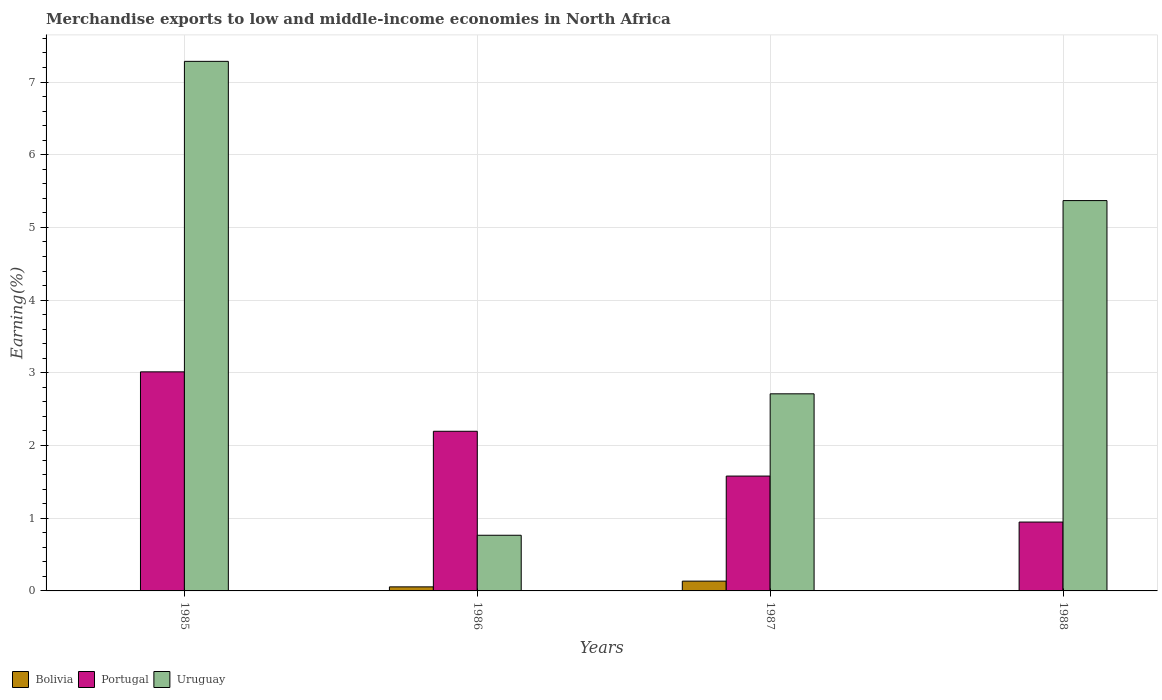How many groups of bars are there?
Provide a short and direct response. 4. How many bars are there on the 2nd tick from the left?
Your answer should be very brief. 3. How many bars are there on the 3rd tick from the right?
Keep it short and to the point. 3. What is the label of the 4th group of bars from the left?
Offer a very short reply. 1988. What is the percentage of amount earned from merchandise exports in Uruguay in 1985?
Offer a very short reply. 7.28. Across all years, what is the maximum percentage of amount earned from merchandise exports in Portugal?
Your answer should be compact. 3.01. Across all years, what is the minimum percentage of amount earned from merchandise exports in Portugal?
Keep it short and to the point. 0.95. In which year was the percentage of amount earned from merchandise exports in Bolivia maximum?
Provide a succinct answer. 1987. What is the total percentage of amount earned from merchandise exports in Bolivia in the graph?
Give a very brief answer. 0.2. What is the difference between the percentage of amount earned from merchandise exports in Portugal in 1985 and that in 1986?
Your response must be concise. 0.82. What is the difference between the percentage of amount earned from merchandise exports in Portugal in 1988 and the percentage of amount earned from merchandise exports in Uruguay in 1985?
Keep it short and to the point. -6.34. What is the average percentage of amount earned from merchandise exports in Uruguay per year?
Give a very brief answer. 4.03. In the year 1985, what is the difference between the percentage of amount earned from merchandise exports in Bolivia and percentage of amount earned from merchandise exports in Portugal?
Your response must be concise. -3.01. What is the ratio of the percentage of amount earned from merchandise exports in Bolivia in 1986 to that in 1988?
Make the answer very short. 13.66. Is the percentage of amount earned from merchandise exports in Bolivia in 1986 less than that in 1988?
Provide a succinct answer. No. Is the difference between the percentage of amount earned from merchandise exports in Bolivia in 1985 and 1988 greater than the difference between the percentage of amount earned from merchandise exports in Portugal in 1985 and 1988?
Your answer should be compact. No. What is the difference between the highest and the second highest percentage of amount earned from merchandise exports in Bolivia?
Ensure brevity in your answer.  0.08. What is the difference between the highest and the lowest percentage of amount earned from merchandise exports in Portugal?
Ensure brevity in your answer.  2.07. In how many years, is the percentage of amount earned from merchandise exports in Portugal greater than the average percentage of amount earned from merchandise exports in Portugal taken over all years?
Offer a very short reply. 2. What does the 2nd bar from the left in 1985 represents?
Keep it short and to the point. Portugal. What does the 1st bar from the right in 1988 represents?
Your answer should be compact. Uruguay. Are all the bars in the graph horizontal?
Your response must be concise. No. How many years are there in the graph?
Make the answer very short. 4. Does the graph contain grids?
Provide a short and direct response. Yes. What is the title of the graph?
Your answer should be compact. Merchandise exports to low and middle-income economies in North Africa. Does "Nepal" appear as one of the legend labels in the graph?
Provide a succinct answer. No. What is the label or title of the X-axis?
Ensure brevity in your answer.  Years. What is the label or title of the Y-axis?
Provide a succinct answer. Earning(%). What is the Earning(%) of Bolivia in 1985?
Your answer should be compact. 0. What is the Earning(%) in Portugal in 1985?
Ensure brevity in your answer.  3.01. What is the Earning(%) of Uruguay in 1985?
Provide a succinct answer. 7.28. What is the Earning(%) in Bolivia in 1986?
Offer a very short reply. 0.06. What is the Earning(%) of Portugal in 1986?
Offer a very short reply. 2.2. What is the Earning(%) of Uruguay in 1986?
Offer a very short reply. 0.77. What is the Earning(%) in Bolivia in 1987?
Your response must be concise. 0.13. What is the Earning(%) of Portugal in 1987?
Give a very brief answer. 1.58. What is the Earning(%) in Uruguay in 1987?
Give a very brief answer. 2.71. What is the Earning(%) of Bolivia in 1988?
Offer a very short reply. 0. What is the Earning(%) of Portugal in 1988?
Give a very brief answer. 0.95. What is the Earning(%) of Uruguay in 1988?
Provide a succinct answer. 5.37. Across all years, what is the maximum Earning(%) in Bolivia?
Keep it short and to the point. 0.13. Across all years, what is the maximum Earning(%) of Portugal?
Ensure brevity in your answer.  3.01. Across all years, what is the maximum Earning(%) of Uruguay?
Keep it short and to the point. 7.28. Across all years, what is the minimum Earning(%) of Bolivia?
Ensure brevity in your answer.  0. Across all years, what is the minimum Earning(%) of Portugal?
Keep it short and to the point. 0.95. Across all years, what is the minimum Earning(%) in Uruguay?
Your response must be concise. 0.77. What is the total Earning(%) in Bolivia in the graph?
Keep it short and to the point. 0.2. What is the total Earning(%) in Portugal in the graph?
Offer a very short reply. 7.74. What is the total Earning(%) of Uruguay in the graph?
Keep it short and to the point. 16.13. What is the difference between the Earning(%) of Bolivia in 1985 and that in 1986?
Your response must be concise. -0.06. What is the difference between the Earning(%) in Portugal in 1985 and that in 1986?
Ensure brevity in your answer.  0.82. What is the difference between the Earning(%) in Uruguay in 1985 and that in 1986?
Offer a terse response. 6.52. What is the difference between the Earning(%) in Bolivia in 1985 and that in 1987?
Give a very brief answer. -0.13. What is the difference between the Earning(%) in Portugal in 1985 and that in 1987?
Make the answer very short. 1.43. What is the difference between the Earning(%) in Uruguay in 1985 and that in 1987?
Give a very brief answer. 4.57. What is the difference between the Earning(%) of Bolivia in 1985 and that in 1988?
Give a very brief answer. -0. What is the difference between the Earning(%) of Portugal in 1985 and that in 1988?
Provide a short and direct response. 2.07. What is the difference between the Earning(%) of Uruguay in 1985 and that in 1988?
Provide a short and direct response. 1.92. What is the difference between the Earning(%) of Bolivia in 1986 and that in 1987?
Give a very brief answer. -0.08. What is the difference between the Earning(%) of Portugal in 1986 and that in 1987?
Your response must be concise. 0.62. What is the difference between the Earning(%) of Uruguay in 1986 and that in 1987?
Keep it short and to the point. -1.95. What is the difference between the Earning(%) of Bolivia in 1986 and that in 1988?
Offer a very short reply. 0.05. What is the difference between the Earning(%) in Portugal in 1986 and that in 1988?
Your answer should be compact. 1.25. What is the difference between the Earning(%) in Uruguay in 1986 and that in 1988?
Provide a short and direct response. -4.6. What is the difference between the Earning(%) of Bolivia in 1987 and that in 1988?
Offer a very short reply. 0.13. What is the difference between the Earning(%) of Portugal in 1987 and that in 1988?
Your answer should be very brief. 0.63. What is the difference between the Earning(%) of Uruguay in 1987 and that in 1988?
Make the answer very short. -2.66. What is the difference between the Earning(%) in Bolivia in 1985 and the Earning(%) in Portugal in 1986?
Offer a very short reply. -2.2. What is the difference between the Earning(%) of Bolivia in 1985 and the Earning(%) of Uruguay in 1986?
Make the answer very short. -0.77. What is the difference between the Earning(%) in Portugal in 1985 and the Earning(%) in Uruguay in 1986?
Make the answer very short. 2.25. What is the difference between the Earning(%) in Bolivia in 1985 and the Earning(%) in Portugal in 1987?
Offer a terse response. -1.58. What is the difference between the Earning(%) in Bolivia in 1985 and the Earning(%) in Uruguay in 1987?
Offer a very short reply. -2.71. What is the difference between the Earning(%) in Portugal in 1985 and the Earning(%) in Uruguay in 1987?
Your response must be concise. 0.3. What is the difference between the Earning(%) of Bolivia in 1985 and the Earning(%) of Portugal in 1988?
Offer a very short reply. -0.95. What is the difference between the Earning(%) of Bolivia in 1985 and the Earning(%) of Uruguay in 1988?
Ensure brevity in your answer.  -5.37. What is the difference between the Earning(%) of Portugal in 1985 and the Earning(%) of Uruguay in 1988?
Provide a short and direct response. -2.36. What is the difference between the Earning(%) of Bolivia in 1986 and the Earning(%) of Portugal in 1987?
Your answer should be compact. -1.52. What is the difference between the Earning(%) in Bolivia in 1986 and the Earning(%) in Uruguay in 1987?
Give a very brief answer. -2.66. What is the difference between the Earning(%) of Portugal in 1986 and the Earning(%) of Uruguay in 1987?
Provide a short and direct response. -0.52. What is the difference between the Earning(%) of Bolivia in 1986 and the Earning(%) of Portugal in 1988?
Keep it short and to the point. -0.89. What is the difference between the Earning(%) in Bolivia in 1986 and the Earning(%) in Uruguay in 1988?
Offer a very short reply. -5.31. What is the difference between the Earning(%) in Portugal in 1986 and the Earning(%) in Uruguay in 1988?
Provide a succinct answer. -3.17. What is the difference between the Earning(%) in Bolivia in 1987 and the Earning(%) in Portugal in 1988?
Offer a terse response. -0.81. What is the difference between the Earning(%) of Bolivia in 1987 and the Earning(%) of Uruguay in 1988?
Make the answer very short. -5.23. What is the difference between the Earning(%) in Portugal in 1987 and the Earning(%) in Uruguay in 1988?
Your answer should be very brief. -3.79. What is the average Earning(%) of Bolivia per year?
Your response must be concise. 0.05. What is the average Earning(%) in Portugal per year?
Provide a short and direct response. 1.93. What is the average Earning(%) of Uruguay per year?
Offer a very short reply. 4.03. In the year 1985, what is the difference between the Earning(%) of Bolivia and Earning(%) of Portugal?
Give a very brief answer. -3.01. In the year 1985, what is the difference between the Earning(%) of Bolivia and Earning(%) of Uruguay?
Give a very brief answer. -7.28. In the year 1985, what is the difference between the Earning(%) in Portugal and Earning(%) in Uruguay?
Ensure brevity in your answer.  -4.27. In the year 1986, what is the difference between the Earning(%) in Bolivia and Earning(%) in Portugal?
Your answer should be compact. -2.14. In the year 1986, what is the difference between the Earning(%) of Bolivia and Earning(%) of Uruguay?
Ensure brevity in your answer.  -0.71. In the year 1986, what is the difference between the Earning(%) in Portugal and Earning(%) in Uruguay?
Your response must be concise. 1.43. In the year 1987, what is the difference between the Earning(%) in Bolivia and Earning(%) in Portugal?
Offer a very short reply. -1.45. In the year 1987, what is the difference between the Earning(%) of Bolivia and Earning(%) of Uruguay?
Your response must be concise. -2.58. In the year 1987, what is the difference between the Earning(%) of Portugal and Earning(%) of Uruguay?
Your response must be concise. -1.13. In the year 1988, what is the difference between the Earning(%) in Bolivia and Earning(%) in Portugal?
Ensure brevity in your answer.  -0.94. In the year 1988, what is the difference between the Earning(%) in Bolivia and Earning(%) in Uruguay?
Your answer should be very brief. -5.37. In the year 1988, what is the difference between the Earning(%) of Portugal and Earning(%) of Uruguay?
Give a very brief answer. -4.42. What is the ratio of the Earning(%) of Bolivia in 1985 to that in 1986?
Keep it short and to the point. 0.01. What is the ratio of the Earning(%) of Portugal in 1985 to that in 1986?
Give a very brief answer. 1.37. What is the ratio of the Earning(%) in Uruguay in 1985 to that in 1986?
Your answer should be very brief. 9.51. What is the ratio of the Earning(%) of Bolivia in 1985 to that in 1987?
Ensure brevity in your answer.  0. What is the ratio of the Earning(%) of Portugal in 1985 to that in 1987?
Keep it short and to the point. 1.91. What is the ratio of the Earning(%) in Uruguay in 1985 to that in 1987?
Provide a succinct answer. 2.69. What is the ratio of the Earning(%) of Bolivia in 1985 to that in 1988?
Provide a short and direct response. 0.15. What is the ratio of the Earning(%) of Portugal in 1985 to that in 1988?
Provide a succinct answer. 3.18. What is the ratio of the Earning(%) of Uruguay in 1985 to that in 1988?
Provide a succinct answer. 1.36. What is the ratio of the Earning(%) in Bolivia in 1986 to that in 1987?
Your answer should be compact. 0.41. What is the ratio of the Earning(%) of Portugal in 1986 to that in 1987?
Your answer should be very brief. 1.39. What is the ratio of the Earning(%) of Uruguay in 1986 to that in 1987?
Your response must be concise. 0.28. What is the ratio of the Earning(%) in Bolivia in 1986 to that in 1988?
Your answer should be compact. 13.66. What is the ratio of the Earning(%) in Portugal in 1986 to that in 1988?
Make the answer very short. 2.32. What is the ratio of the Earning(%) of Uruguay in 1986 to that in 1988?
Make the answer very short. 0.14. What is the ratio of the Earning(%) in Bolivia in 1987 to that in 1988?
Make the answer very short. 32.98. What is the ratio of the Earning(%) of Portugal in 1987 to that in 1988?
Provide a succinct answer. 1.67. What is the ratio of the Earning(%) in Uruguay in 1987 to that in 1988?
Give a very brief answer. 0.5. What is the difference between the highest and the second highest Earning(%) of Bolivia?
Your response must be concise. 0.08. What is the difference between the highest and the second highest Earning(%) of Portugal?
Provide a succinct answer. 0.82. What is the difference between the highest and the second highest Earning(%) of Uruguay?
Offer a terse response. 1.92. What is the difference between the highest and the lowest Earning(%) in Bolivia?
Give a very brief answer. 0.13. What is the difference between the highest and the lowest Earning(%) in Portugal?
Provide a succinct answer. 2.07. What is the difference between the highest and the lowest Earning(%) of Uruguay?
Provide a succinct answer. 6.52. 